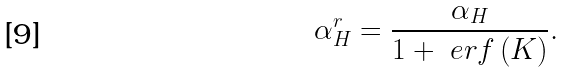<formula> <loc_0><loc_0><loc_500><loc_500>\alpha _ { H } ^ { r } = \frac { \alpha _ { H } } { 1 + \ e r f \left ( K \right ) } .</formula> 